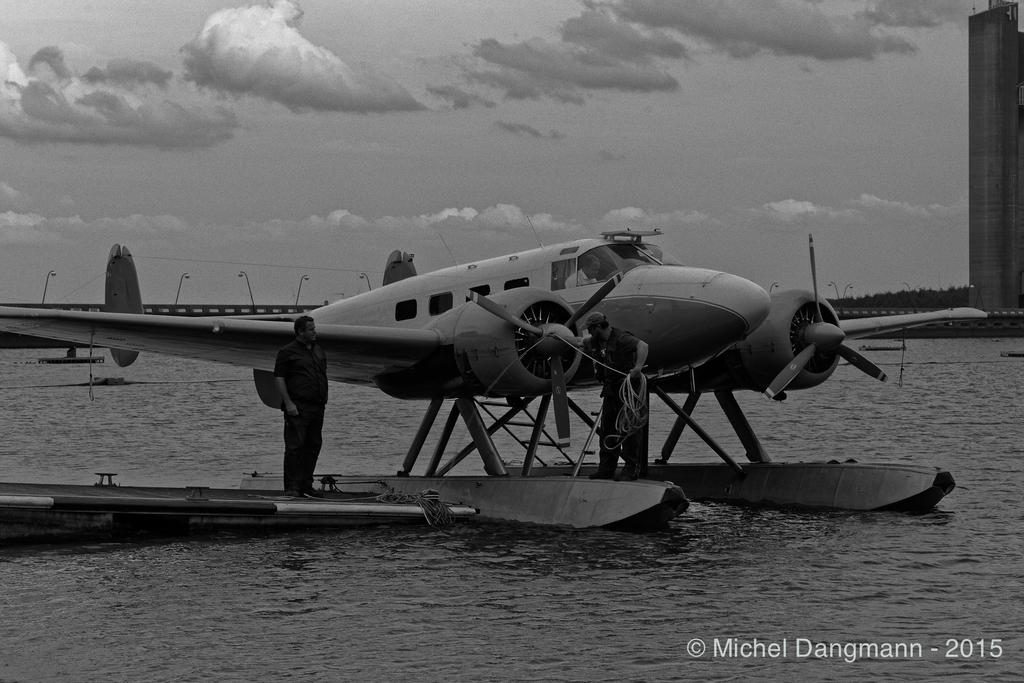<image>
Present a compact description of the photo's key features. a black and white old sea plane taken by Michel Dangmann in 2015 